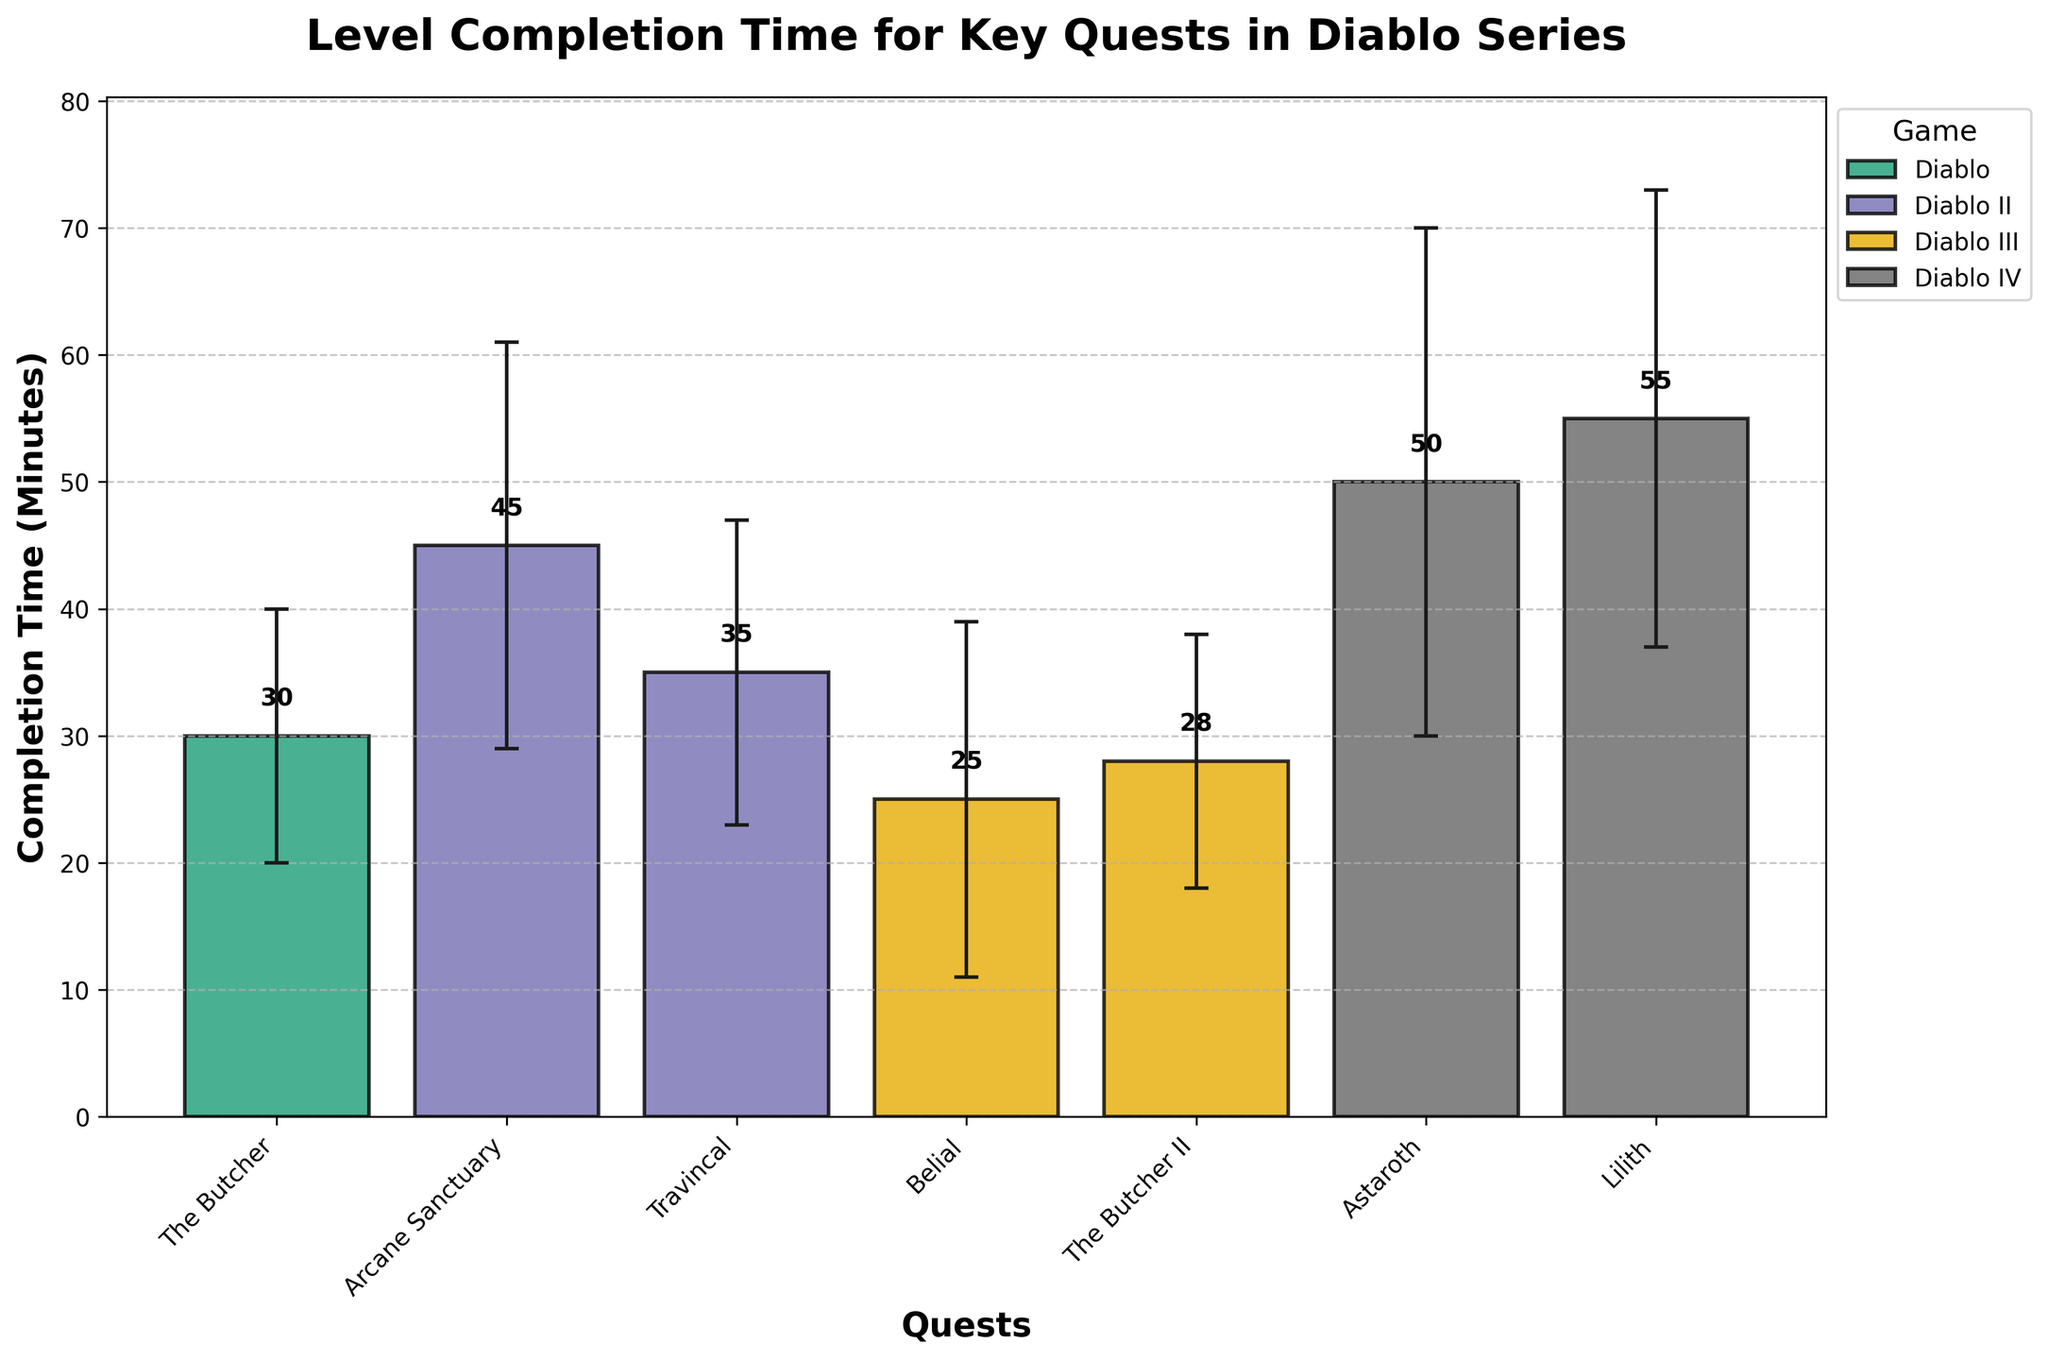What's the title of the bar chart? The title is prominently displayed at the top of the bar chart.
Answer: Level Completion Time for Key Quests in Diablo Series Which quest in Diablo IV has the highest mean completion time? In the Diablo IV section, the quest "Lilith" has a higher mean completion time than "Astaroth," as indicated by the height of the bars.
Answer: Lilith What's the mean completion time for the quest "Belial" in Diablo III? The bar labeled "Belial" in the Diablo III section shows the mean completion time at the top of the bar.
Answer: 25 minutes Compare the mean completion times of "The Butcher" in Diablo and "Astaroth" in Diablo IV. Which one is higher and by how much? Subtract the mean completion time of "The Butcher" (30 minutes) from that of "Astaroth" (50 minutes).
Answer: Astaroth is higher by 20 minutes What's the range of the confidence interval for "Travincal" in Diablo II? The confidence interval lower and upper bounds for "Travincal" are 23 and 47 minutes, respectively. The range can be found by subtracting the lower bound from the upper bound.
Answer: 24 minutes Which game has the highest variability in completion times for its quests? Look for the game with the highest standard deviations listed. Diablo IV has 9 and 10 minutes for "Lilith" and "Astaroth," which are higher than those for other games.
Answer: Diablo IV Calculate the average mean completion time of all quests listed in the chart. Sum the mean completion times (30 + 45 + 35 + 25 + 28 + 50 + 55) and divide by the number of quests (7).
Answer: 38.6 minutes Does "Arcane Sanctuary" in Diablo II have a larger confidence interval than "The Butcher II" in Diablo III? Compare the length of the confidence intervals for "Arcane Sanctuary" (61 - 29 = 32) and "The Butcher II" (38 - 18 = 20).
Answer: Yes Which quest has the lowest upper bound of its confidence interval, and what is this value? Examine all upper bounds of confidence intervals in the table and identify the lowest one. "Belial" in Diablo III has the lowest upper bound at 39.
Answer: Belial, 39 minutes Are the error bars for "Lilith" in Diablo IV longer than those for "The Butcher II" in Diablo III? Compare the length of the error bars for both quests. "Lilith's" error bars range from 37 to 73 (difference of 36), whereas "The Butcher II's" range from 18 to 38 (difference of 20).
Answer: Yes 